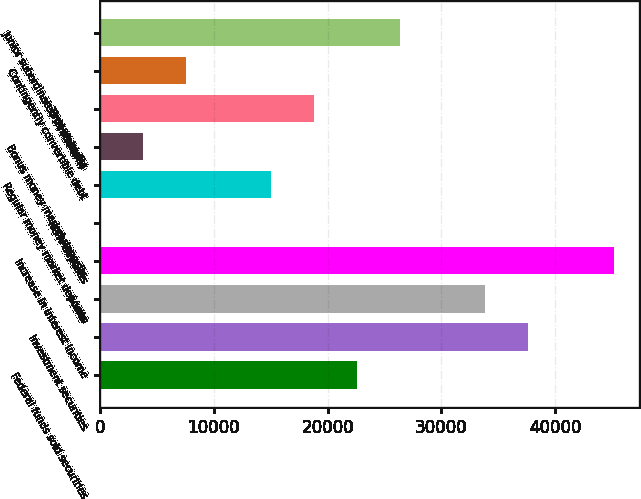Convert chart to OTSL. <chart><loc_0><loc_0><loc_500><loc_500><bar_chart><fcel>Federal funds sold securities<fcel>Investment securities<fcel>Loans<fcel>Increase in interest income<fcel>NOW deposits<fcel>Regular money market deposits<fcel>Bonus money market deposits<fcel>Time deposits<fcel>Contingently convertible debt<fcel>Junior subordinated debentures<nl><fcel>22581.8<fcel>37629<fcel>33867.2<fcel>45152.6<fcel>11<fcel>15058.2<fcel>3772.8<fcel>18820<fcel>7534.6<fcel>26343.6<nl></chart> 